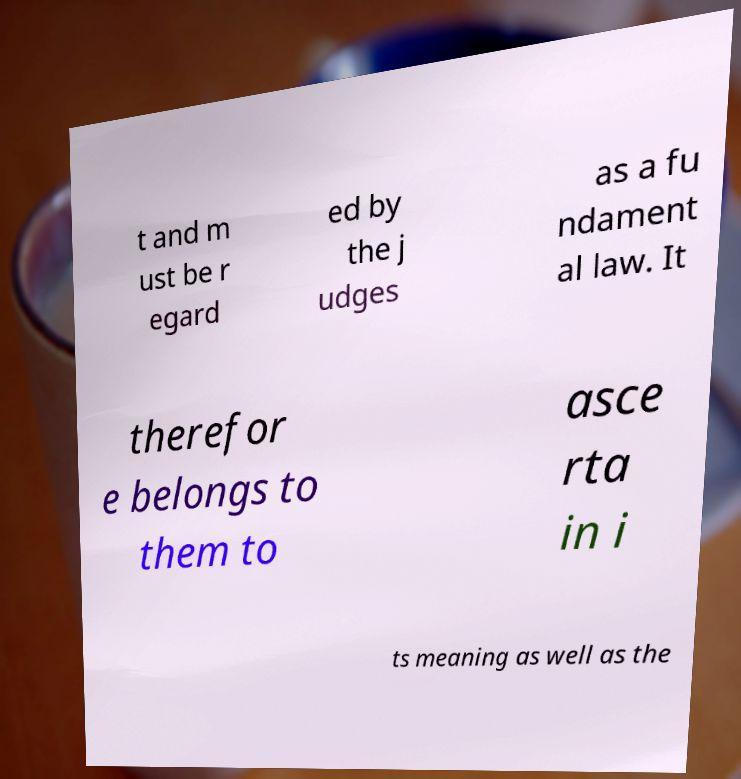Could you assist in decoding the text presented in this image and type it out clearly? t and m ust be r egard ed by the j udges as a fu ndament al law. It therefor e belongs to them to asce rta in i ts meaning as well as the 